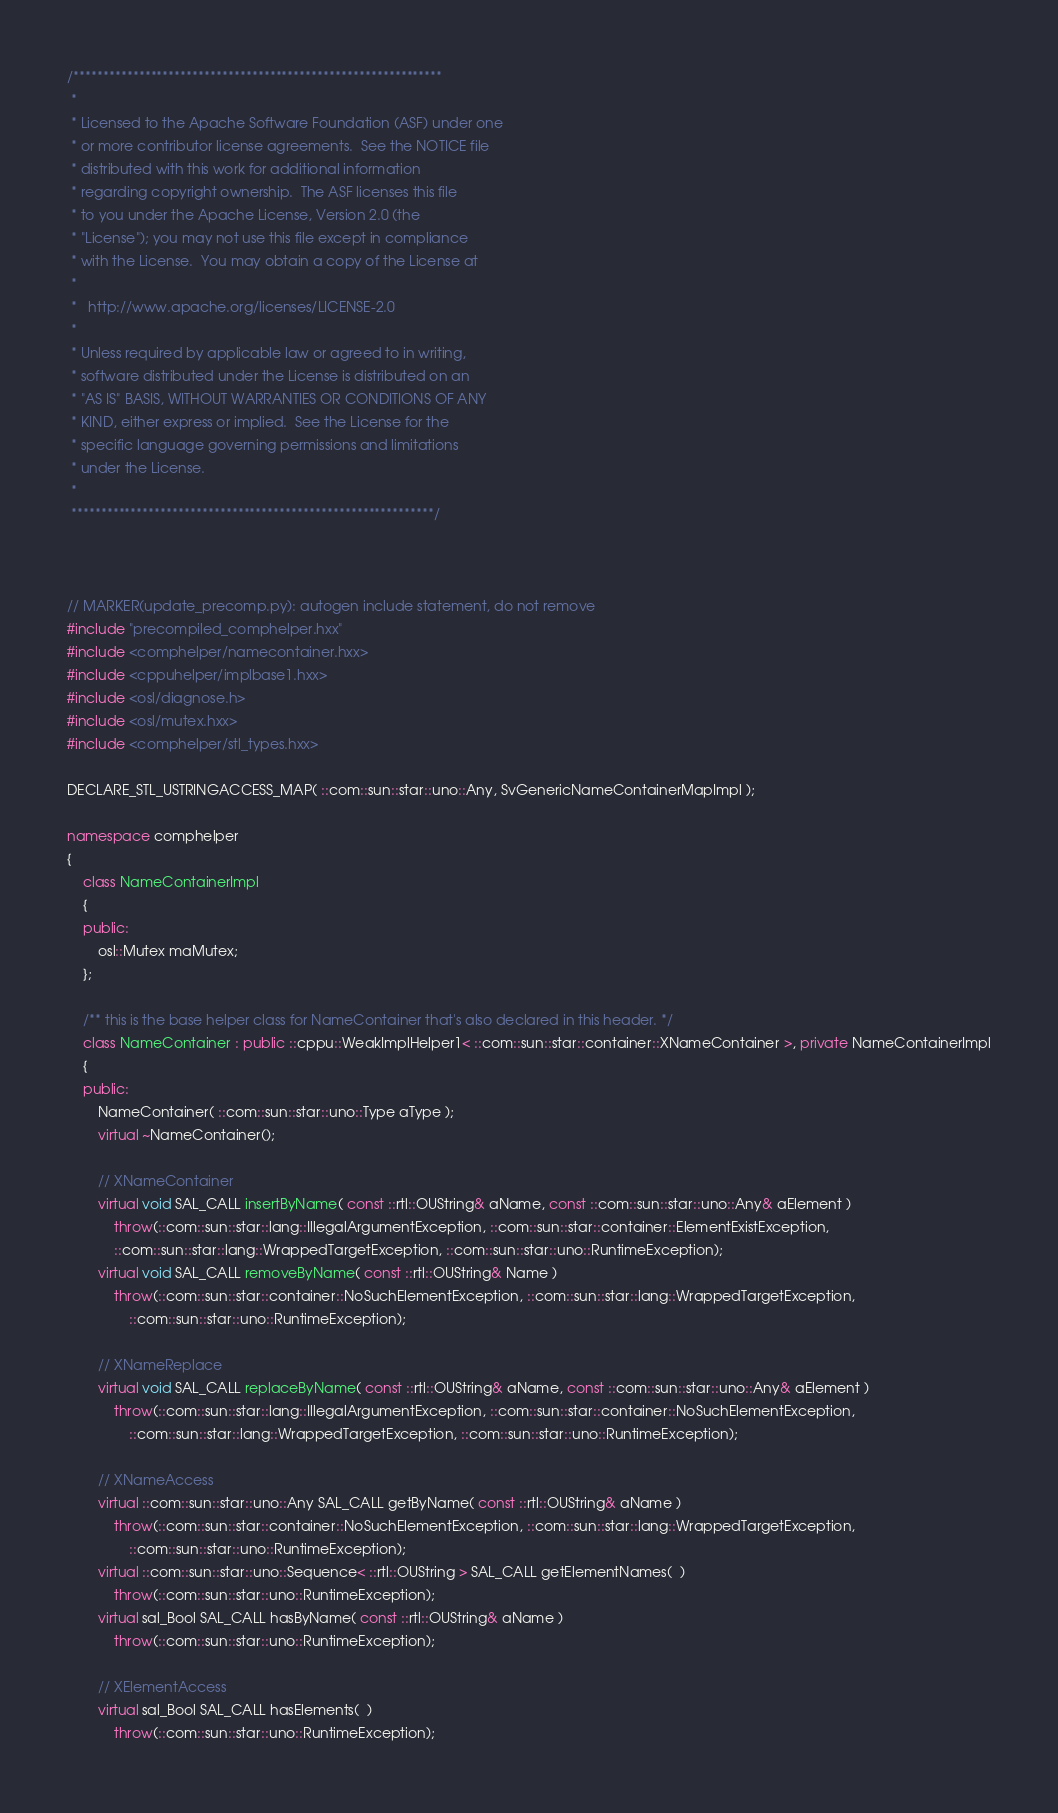<code> <loc_0><loc_0><loc_500><loc_500><_C++_>/**************************************************************
 * 
 * Licensed to the Apache Software Foundation (ASF) under one
 * or more contributor license agreements.  See the NOTICE file
 * distributed with this work for additional information
 * regarding copyright ownership.  The ASF licenses this file
 * to you under the Apache License, Version 2.0 (the
 * "License"); you may not use this file except in compliance
 * with the License.  You may obtain a copy of the License at
 * 
 *   http://www.apache.org/licenses/LICENSE-2.0
 * 
 * Unless required by applicable law or agreed to in writing,
 * software distributed under the License is distributed on an
 * "AS IS" BASIS, WITHOUT WARRANTIES OR CONDITIONS OF ANY
 * KIND, either express or implied.  See the License for the
 * specific language governing permissions and limitations
 * under the License.
 * 
 *************************************************************/



// MARKER(update_precomp.py): autogen include statement, do not remove
#include "precompiled_comphelper.hxx"
#include <comphelper/namecontainer.hxx>
#include <cppuhelper/implbase1.hxx>
#include <osl/diagnose.h>
#include <osl/mutex.hxx>
#include <comphelper/stl_types.hxx>

DECLARE_STL_USTRINGACCESS_MAP( ::com::sun::star::uno::Any, SvGenericNameContainerMapImpl );

namespace comphelper
{
	class NameContainerImpl
	{
	public:
		osl::Mutex maMutex;
	};

	/** this is the base helper class for NameContainer that's also declared in this header. */
	class NameContainer : public ::cppu::WeakImplHelper1< ::com::sun::star::container::XNameContainer >, private NameContainerImpl
	{
	public:
		NameContainer( ::com::sun::star::uno::Type aType );
		virtual ~NameContainer();

		// XNameContainer
		virtual void SAL_CALL insertByName( const ::rtl::OUString& aName, const ::com::sun::star::uno::Any& aElement )
			throw(::com::sun::star::lang::IllegalArgumentException, ::com::sun::star::container::ElementExistException,
			::com::sun::star::lang::WrappedTargetException, ::com::sun::star::uno::RuntimeException);
		virtual void SAL_CALL removeByName( const ::rtl::OUString& Name )
			throw(::com::sun::star::container::NoSuchElementException, ::com::sun::star::lang::WrappedTargetException,
				::com::sun::star::uno::RuntimeException);

		// XNameReplace
		virtual void SAL_CALL replaceByName( const ::rtl::OUString& aName, const ::com::sun::star::uno::Any& aElement )
			throw(::com::sun::star::lang::IllegalArgumentException, ::com::sun::star::container::NoSuchElementException,
				::com::sun::star::lang::WrappedTargetException, ::com::sun::star::uno::RuntimeException);

		// XNameAccess
		virtual ::com::sun::star::uno::Any SAL_CALL getByName( const ::rtl::OUString& aName )
			throw(::com::sun::star::container::NoSuchElementException, ::com::sun::star::lang::WrappedTargetException,
				::com::sun::star::uno::RuntimeException);
		virtual ::com::sun::star::uno::Sequence< ::rtl::OUString > SAL_CALL getElementNames(  )
			throw(::com::sun::star::uno::RuntimeException);
		virtual sal_Bool SAL_CALL hasByName( const ::rtl::OUString& aName )
			throw(::com::sun::star::uno::RuntimeException);

		// XElementAccess
		virtual sal_Bool SAL_CALL hasElements(  )
			throw(::com::sun::star::uno::RuntimeException);</code> 